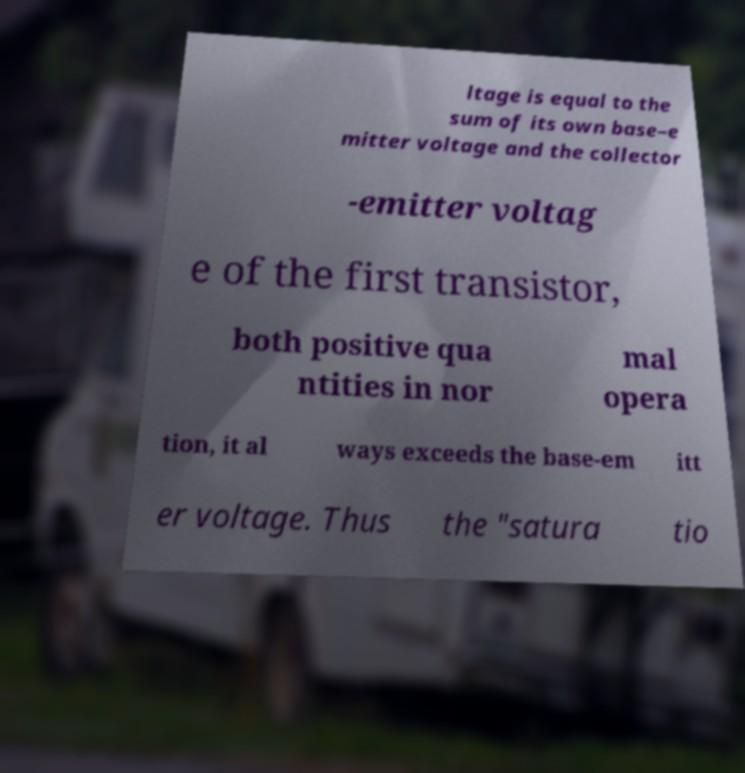What messages or text are displayed in this image? I need them in a readable, typed format. ltage is equal to the sum of its own base–e mitter voltage and the collector -emitter voltag e of the first transistor, both positive qua ntities in nor mal opera tion, it al ways exceeds the base-em itt er voltage. Thus the "satura tio 